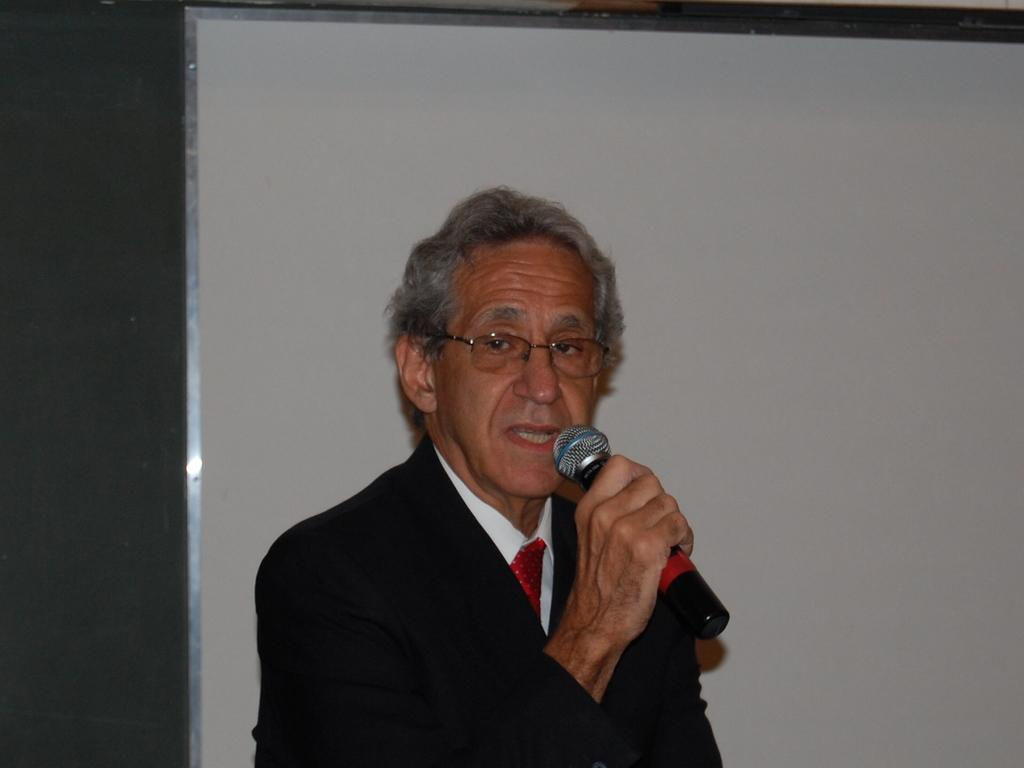What is the man in the image holding in his hand? The man is holding a mic in his hand. What is the man doing with the mic? The man is talking while holding the mic. Can you describe the man's attire in the image? The man is wearing a blazer, spectacles, and a tie. What is visible in the background of the image? There is a wall in the background of the image. What type of crime is being committed in the image? There is no crime being committed in the image; it features a man holding a mic and talking. How does the man use his income to improve his skateboarding skills in the image? There is no mention of income or skateboarding in the image; it focuses on the man holding a mic and talking. 